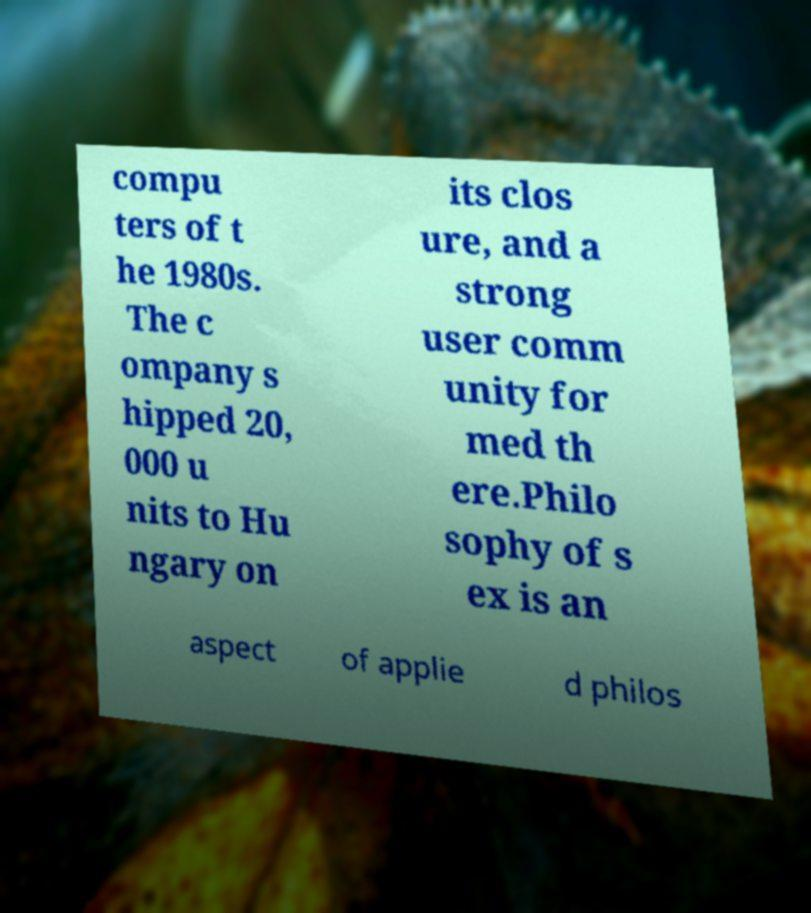What messages or text are displayed in this image? I need them in a readable, typed format. compu ters of t he 1980s. The c ompany s hipped 20, 000 u nits to Hu ngary on its clos ure, and a strong user comm unity for med th ere.Philo sophy of s ex is an aspect of applie d philos 